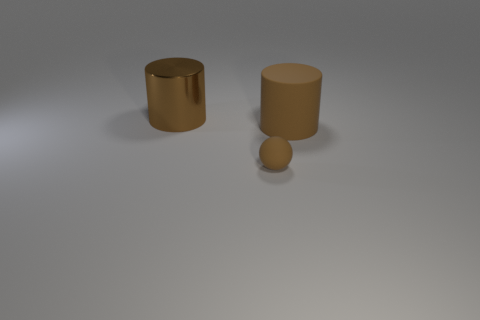There is a cylinder that is to the left of the matte cylinder; are there any large brown cylinders that are right of it?
Give a very brief answer. Yes. Are there fewer brown shiny things that are to the right of the sphere than metallic cylinders that are left of the shiny cylinder?
Provide a short and direct response. No. Is there any other thing that has the same size as the sphere?
Ensure brevity in your answer.  No. There is a big brown metallic thing; what shape is it?
Offer a terse response. Cylinder. There is a big brown thing that is left of the large brown rubber object; what material is it?
Offer a terse response. Metal. There is a brown sphere that is right of the brown cylinder that is behind the big thing that is to the right of the big metallic object; how big is it?
Keep it short and to the point. Small. Is the material of the big brown object that is on the left side of the brown ball the same as the large cylinder that is to the right of the small brown rubber sphere?
Your response must be concise. No. What number of other things are there of the same color as the big matte object?
Your answer should be very brief. 2. What number of objects are either brown cylinders to the right of the metal cylinder or brown objects that are to the left of the large rubber cylinder?
Offer a terse response. 3. There is a brown rubber object that is on the left side of the brown cylinder in front of the brown metal cylinder; how big is it?
Your answer should be very brief. Small. 